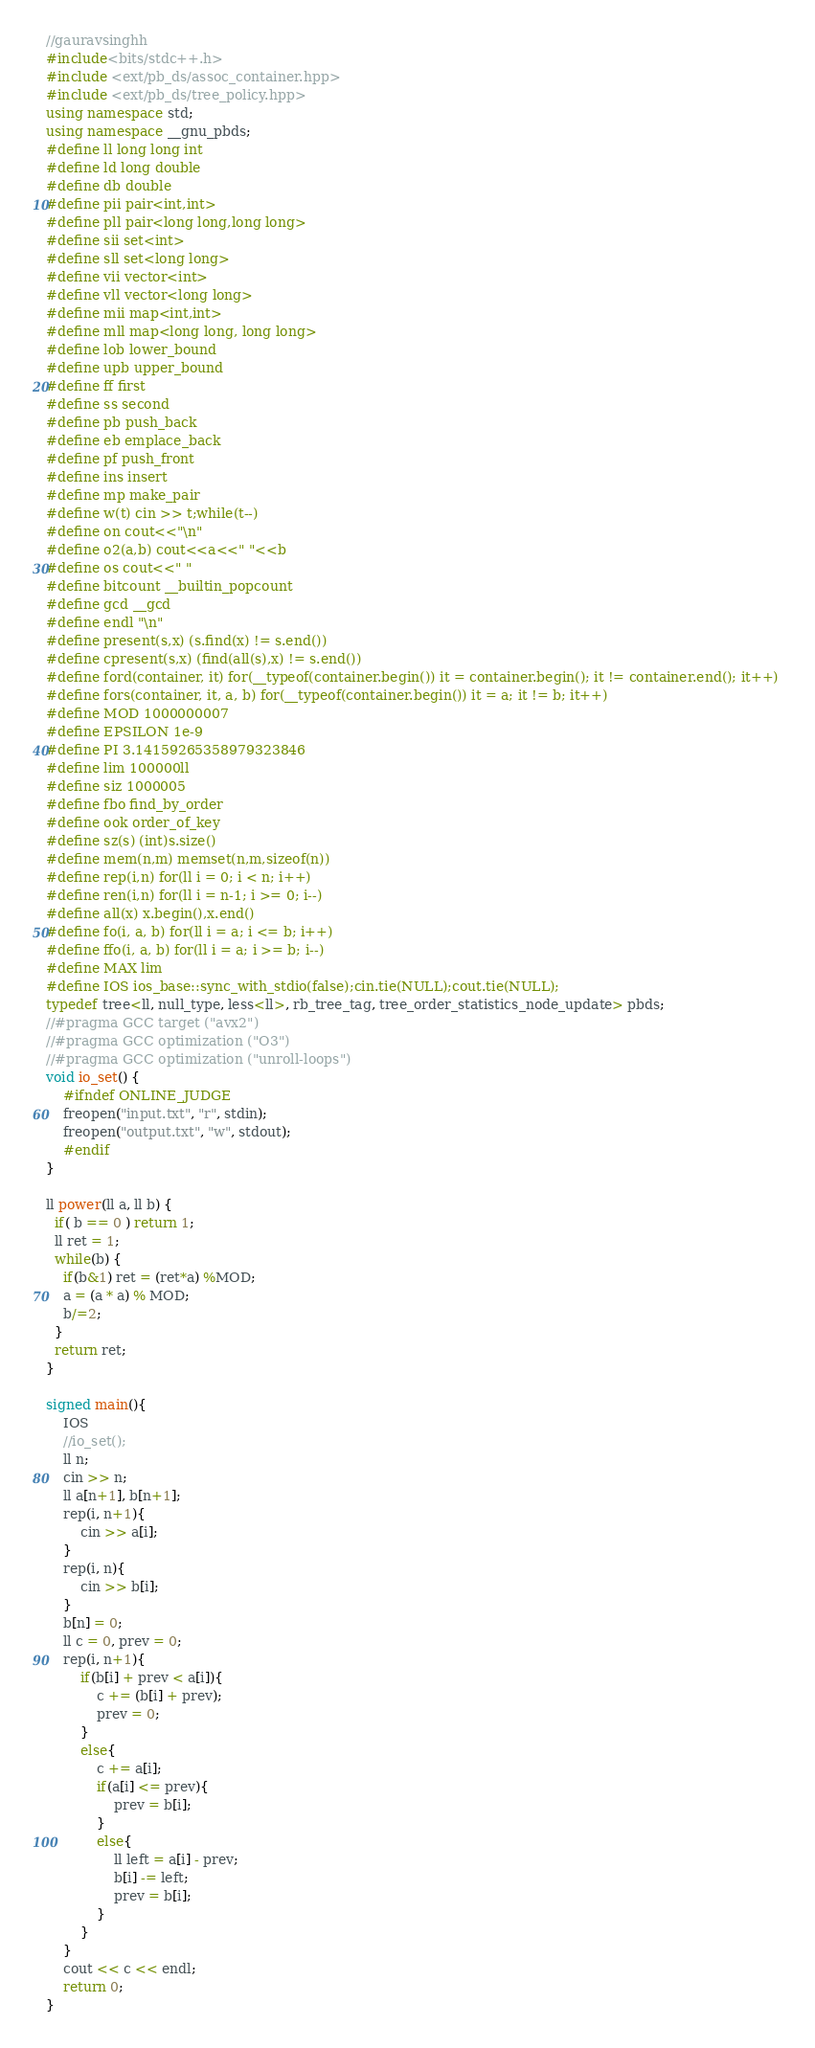Convert code to text. <code><loc_0><loc_0><loc_500><loc_500><_C++_>//gauravsinghh
#include<bits/stdc++.h>
#include <ext/pb_ds/assoc_container.hpp>
#include <ext/pb_ds/tree_policy.hpp>
using namespace std;
using namespace __gnu_pbds;
#define ll long long int
#define ld long double
#define db double
#define pii pair<int,int>
#define pll pair<long long,long long>
#define sii set<int>
#define sll set<long long>
#define vii vector<int> 
#define vll vector<long long>
#define mii map<int,int>
#define mll map<long long, long long>
#define lob lower_bound
#define upb upper_bound
#define ff first
#define ss second
#define pb push_back
#define eb emplace_back
#define pf push_front
#define ins insert
#define mp make_pair
#define w(t) cin >> t;while(t--)
#define on cout<<"\n"
#define o2(a,b) cout<<a<<" "<<b
#define os cout<<" "
#define bitcount __builtin_popcount
#define gcd __gcd
#define endl "\n"
#define present(s,x) (s.find(x) != s.end()) 
#define cpresent(s,x) (find(all(s),x) != s.end()) 
#define ford(container, it) for(__typeof(container.begin()) it = container.begin(); it != container.end(); it++) 
#define fors(container, it, a, b) for(__typeof(container.begin()) it = a; it != b; it++) 
#define MOD 1000000007
#define EPSILON 1e-9
#define PI 3.14159265358979323846
#define lim 100000ll
#define siz 1000005
#define fbo find_by_order
#define ook order_of_key
#define sz(s) (int)s.size()
#define mem(n,m) memset(n,m,sizeof(n))
#define rep(i,n) for(ll i = 0; i < n; i++)
#define ren(i,n) for(ll i = n-1; i >= 0; i--)
#define all(x) x.begin(),x.end()
#define fo(i, a, b) for(ll i = a; i <= b; i++)
#define ffo(i, a, b) for(ll i = a; i >= b; i--)
#define MAX lim
#define IOS ios_base::sync_with_stdio(false);cin.tie(NULL);cout.tie(NULL);
typedef tree<ll, null_type, less<ll>, rb_tree_tag, tree_order_statistics_node_update> pbds;
//#pragma GCC target ("avx2")
//#pragma GCC optimization ("O3")
//#pragma GCC optimization ("unroll-loops")
void io_set() {
    #ifndef ONLINE_JUDGE
    freopen("input.txt", "r", stdin);
    freopen("output.txt", "w", stdout);
    #endif
}

ll power(ll a, ll b) {
  if( b == 0 ) return 1;
  ll ret = 1;
  while(b) {
    if(b&1) ret = (ret*a) %MOD;
    a = (a * a) % MOD;
    b/=2;
  }
  return ret;
}

signed main(){ 
    IOS
    //io_set();
    ll n;
    cin >> n;
    ll a[n+1], b[n+1];
    rep(i, n+1){
        cin >> a[i];
    }
    rep(i, n){
        cin >> b[i];
    }
    b[n] = 0;
    ll c = 0, prev = 0;
    rep(i, n+1){
        if(b[i] + prev < a[i]){
            c += (b[i] + prev);
            prev = 0;
        }
        else{
            c += a[i];
            if(a[i] <= prev){
                prev = b[i];
            }
            else{
                ll left = a[i] - prev;
                b[i] -= left;
                prev = b[i];
            }
        }
    }
    cout << c << endl;
    return 0;
} </code> 